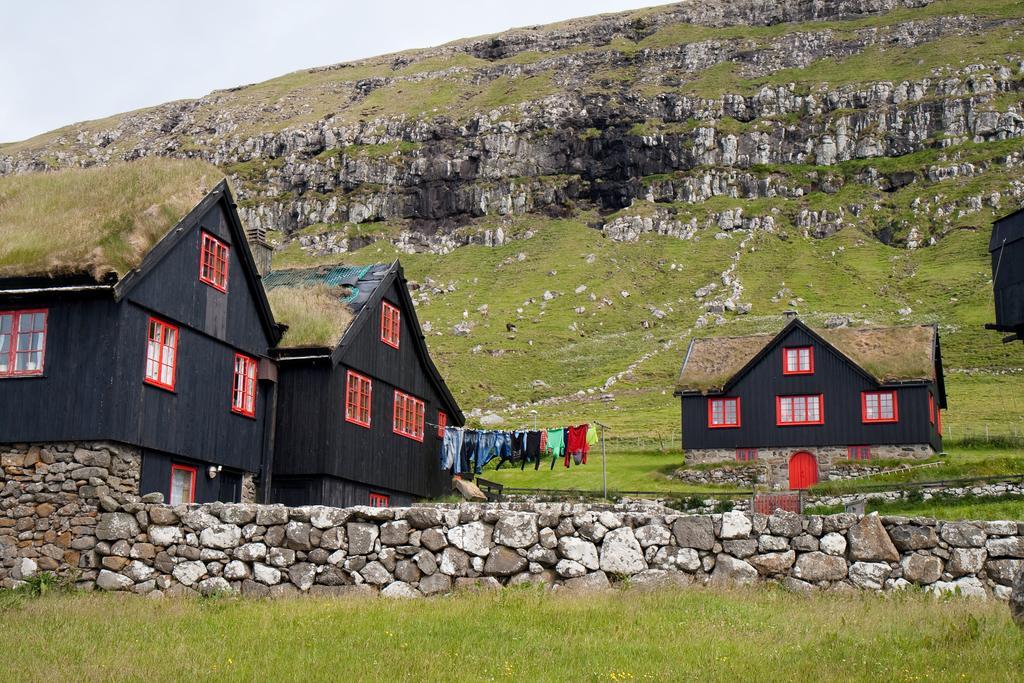Describe this image in one or two sentences. In this image we can see a group of houses with windows, roof and doors. We can also see some grass on the roof and some clothes hanged to a rope. On the bottom of the image we can see some stones and grass. On the backside we can see the hill and the sky which looks cloudy. 